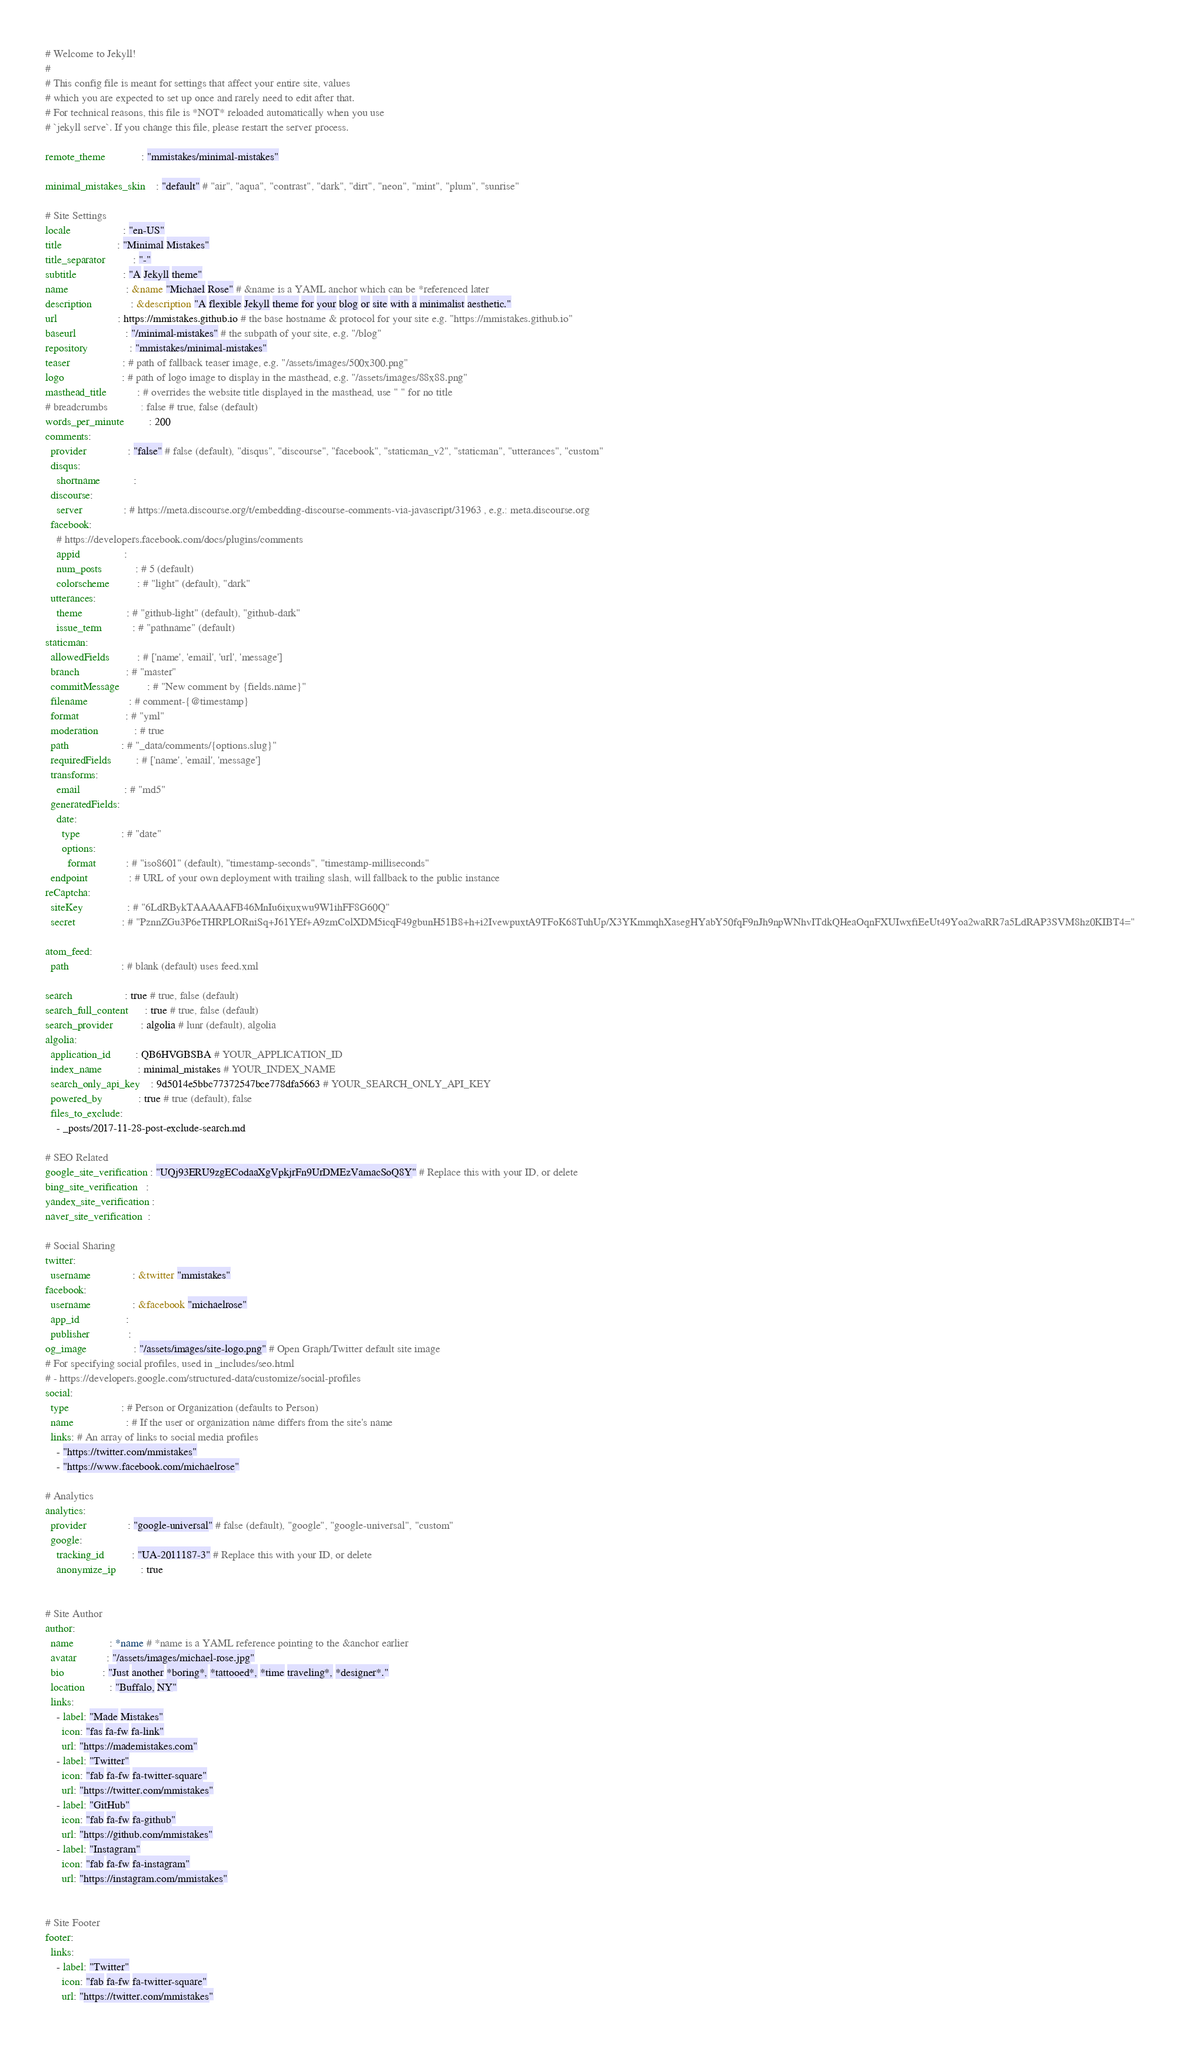<code> <loc_0><loc_0><loc_500><loc_500><_YAML_># Welcome to Jekyll!
#
# This config file is meant for settings that affect your entire site, values
# which you are expected to set up once and rarely need to edit after that.
# For technical reasons, this file is *NOT* reloaded automatically when you use
# `jekyll serve`. If you change this file, please restart the server process.

remote_theme             : "mmistakes/minimal-mistakes"

minimal_mistakes_skin    : "default" # "air", "aqua", "contrast", "dark", "dirt", "neon", "mint", "plum", "sunrise"

# Site Settings
locale                   : "en-US"
title                    : "Minimal Mistakes"
title_separator          : "-"
subtitle                 : "A Jekyll theme"
name                     : &name "Michael Rose" # &name is a YAML anchor which can be *referenced later
description              : &description "A flexible Jekyll theme for your blog or site with a minimalist aesthetic."
url                      : https://mmistakes.github.io # the base hostname & protocol for your site e.g. "https://mmistakes.github.io"
baseurl                  : "/minimal-mistakes" # the subpath of your site, e.g. "/blog"
repository               : "mmistakes/minimal-mistakes"
teaser                   : # path of fallback teaser image, e.g. "/assets/images/500x300.png"
logo                     : # path of logo image to display in the masthead, e.g. "/assets/images/88x88.png"
masthead_title           : # overrides the website title displayed in the masthead, use " " for no title
# breadcrumbs            : false # true, false (default)
words_per_minute         : 200
comments:
  provider               : "false" # false (default), "disqus", "discourse", "facebook", "staticman_v2", "staticman", "utterances", "custom"
  disqus:
    shortname            :
  discourse:
    server               : # https://meta.discourse.org/t/embedding-discourse-comments-via-javascript/31963 , e.g.: meta.discourse.org
  facebook:
    # https://developers.facebook.com/docs/plugins/comments
    appid                :
    num_posts            : # 5 (default)
    colorscheme          : # "light" (default), "dark"
  utterances:
    theme                : # "github-light" (default), "github-dark"
    issue_term           : # "pathname" (default)
staticman:
  allowedFields          : # ['name', 'email', 'url', 'message']
  branch                 : # "master"
  commitMessage          : # "New comment by {fields.name}"
  filename               : # comment-{@timestamp}
  format                 : # "yml"
  moderation             : # true
  path                   : # "_data/comments/{options.slug}"
  requiredFields         : # ['name', 'email', 'message']
  transforms:
    email                : # "md5"
  generatedFields:
    date:
      type               : # "date"
      options:
        format           : # "iso8601" (default), "timestamp-seconds", "timestamp-milliseconds"
  endpoint               : # URL of your own deployment with trailing slash, will fallback to the public instance
reCaptcha:
  siteKey                : # "6LdRBykTAAAAAFB46MnIu6ixuxwu9W1ihFF8G60Q"
  secret                 : # "PznnZGu3P6eTHRPLORniSq+J61YEf+A9zmColXDM5icqF49gbunH51B8+h+i2IvewpuxtA9TFoK68TuhUp/X3YKmmqhXasegHYabY50fqF9nJh9npWNhvITdkQHeaOqnFXUIwxfiEeUt49Yoa2waRR7a5LdRAP3SVM8hz0KIBT4="

atom_feed:
  path                   : # blank (default) uses feed.xml

search                   : true # true, false (default)
search_full_content      : true # true, false (default)
search_provider          : algolia # lunr (default), algolia
algolia:
  application_id         : QB6HVGBSBA # YOUR_APPLICATION_ID
  index_name             : minimal_mistakes # YOUR_INDEX_NAME
  search_only_api_key    : 9d5014e5bbc77372547bce778dfa5663 # YOUR_SEARCH_ONLY_API_KEY
  powered_by             : true # true (default), false
  files_to_exclude:
    - _posts/2017-11-28-post-exclude-search.md

# SEO Related
google_site_verification : "UQj93ERU9zgECodaaXgVpkjrFn9UrDMEzVamacSoQ8Y" # Replace this with your ID, or delete
bing_site_verification   :
yandex_site_verification :
naver_site_verification  :

# Social Sharing
twitter:
  username               : &twitter "mmistakes"
facebook:
  username               : &facebook "michaelrose"
  app_id                 :
  publisher              :
og_image                 : "/assets/images/site-logo.png" # Open Graph/Twitter default site image
# For specifying social profiles, used in _includes/seo.html
# - https://developers.google.com/structured-data/customize/social-profiles
social:
  type                   : # Person or Organization (defaults to Person)
  name                   : # If the user or organization name differs from the site's name
  links: # An array of links to social media profiles
    - "https://twitter.com/mmistakes"
    - "https://www.facebook.com/michaelrose"

# Analytics
analytics:
  provider               : "google-universal" # false (default), "google", "google-universal", "custom"
  google:
    tracking_id          : "UA-2011187-3" # Replace this with your ID, or delete
    anonymize_ip         : true


# Site Author
author:
  name             : *name # *name is a YAML reference pointing to the &anchor earlier
  avatar           : "/assets/images/michael-rose.jpg"
  bio              : "Just another *boring*, *tattooed*, *time traveling*, *designer*."
  location         : "Buffalo, NY"
  links:
    - label: "Made Mistakes"
      icon: "fas fa-fw fa-link"
      url: "https://mademistakes.com"
    - label: "Twitter"
      icon: "fab fa-fw fa-twitter-square"
      url: "https://twitter.com/mmistakes"
    - label: "GitHub"
      icon: "fab fa-fw fa-github"
      url: "https://github.com/mmistakes"
    - label: "Instagram"
      icon: "fab fa-fw fa-instagram"
      url: "https://instagram.com/mmistakes"


# Site Footer
footer:
  links:
    - label: "Twitter"
      icon: "fab fa-fw fa-twitter-square"
      url: "https://twitter.com/mmistakes"</code> 